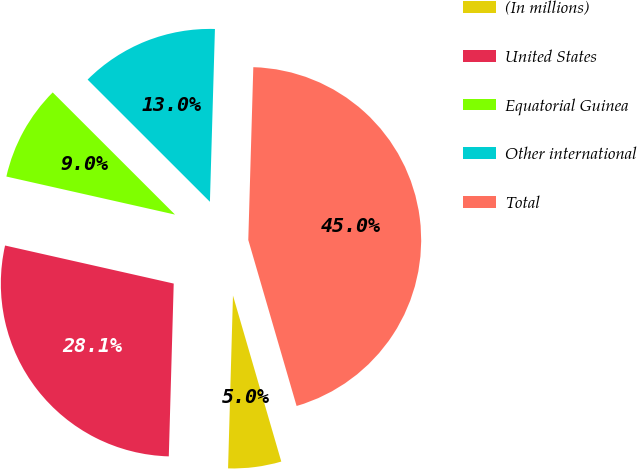<chart> <loc_0><loc_0><loc_500><loc_500><pie_chart><fcel>(In millions)<fcel>United States<fcel>Equatorial Guinea<fcel>Other international<fcel>Total<nl><fcel>4.96%<fcel>28.08%<fcel>8.96%<fcel>12.97%<fcel>45.03%<nl></chart> 